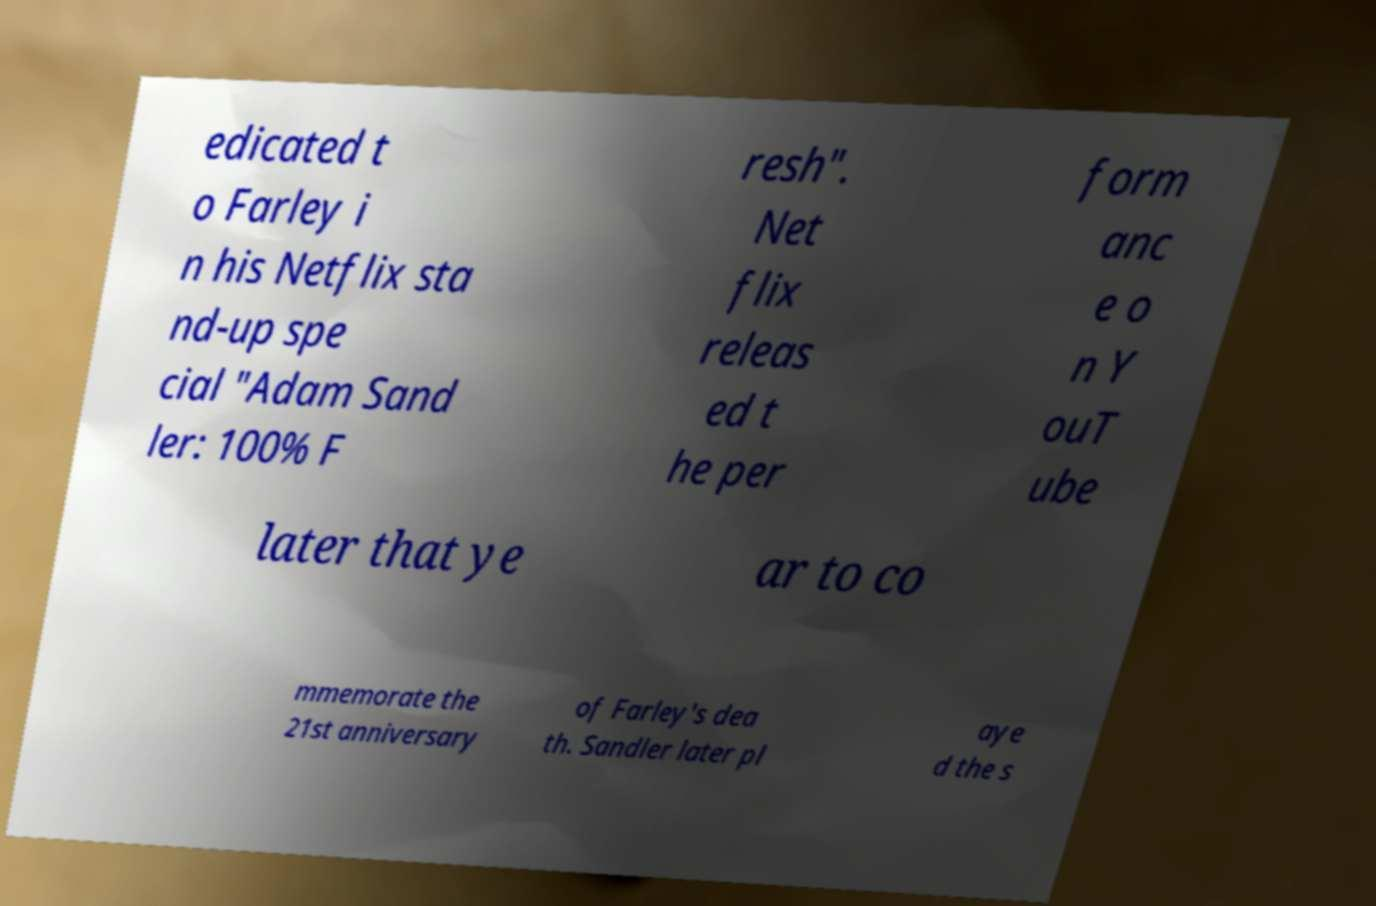What messages or text are displayed in this image? I need them in a readable, typed format. edicated t o Farley i n his Netflix sta nd-up spe cial "Adam Sand ler: 100% F resh". Net flix releas ed t he per form anc e o n Y ouT ube later that ye ar to co mmemorate the 21st anniversary of Farley's dea th. Sandler later pl aye d the s 